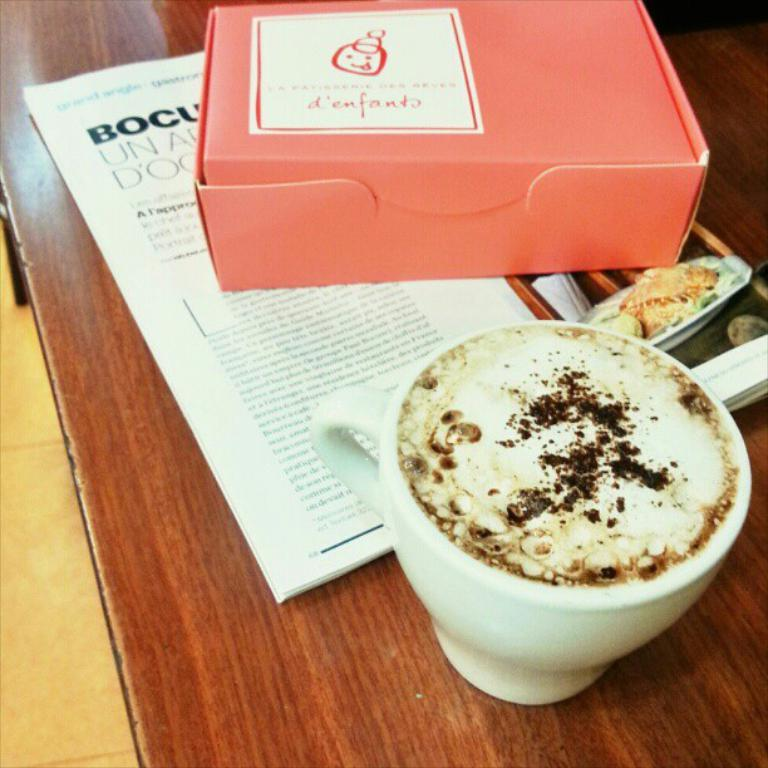What is the main object in the center of the image? There is a table in the center of the image. What items can be seen on the table? There is a cup, a book, and a box on the table. What time is indicated on the clock in the image? There is no clock present in the image, so we cannot determine the time. 